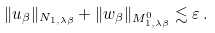<formula> <loc_0><loc_0><loc_500><loc_500>\| u _ { \beta } \| _ { N _ { 1 , \lambda \beta } } + \| w _ { \beta } \| _ { M ^ { 0 } _ { 1 , \lambda \beta } } \lesssim \varepsilon \, .</formula> 